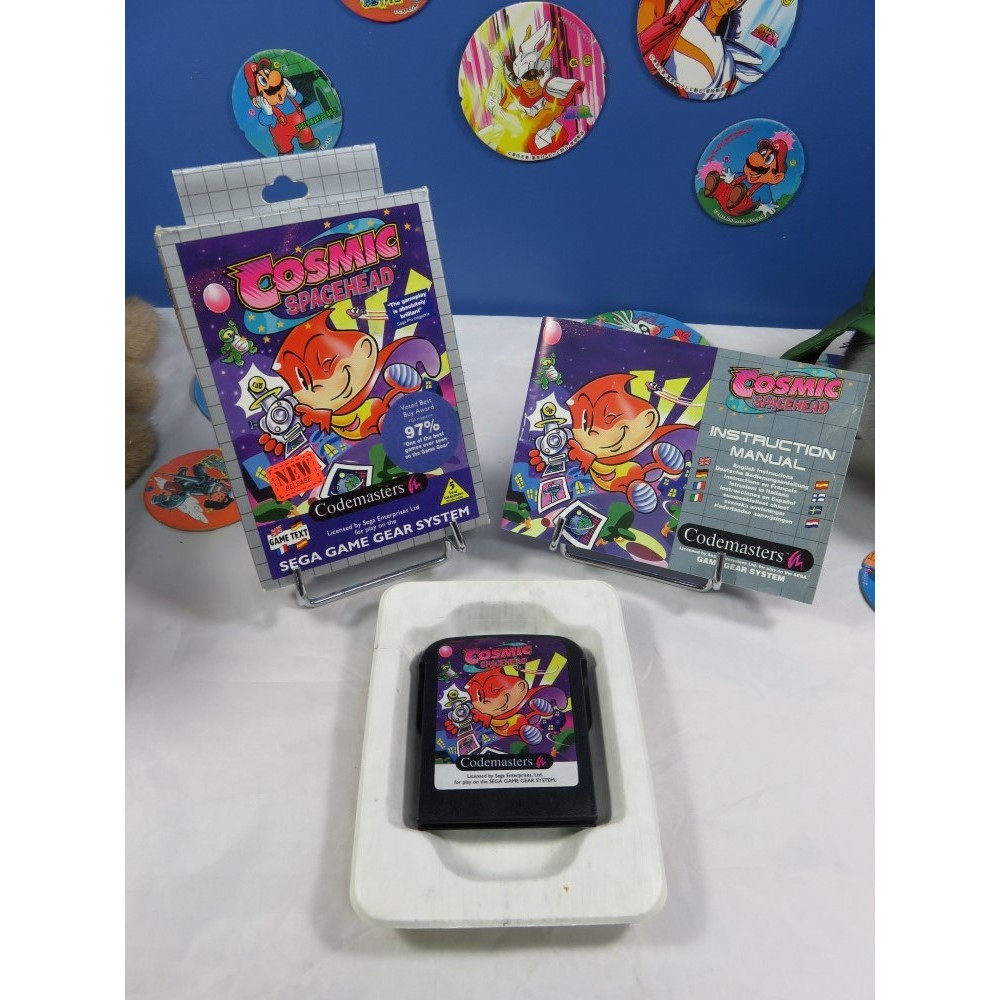Considering the elements presented, what can be deduced about the marketing strategy used for the "Cosmic Spacehead" game based on the promotional materials and packaging shown? Based on the promotional materials and packaging shown in the image, the marketing strategy for "Cosmic Spacehead" appears to be heavily focused on visually appealing and colorful artwork to captivate potential buyers. The prominent use of vibrant character designs and a high review score (97%) on the packaging suggests a strategy aimed at reassuring customers about the game's quality and entertainment value. The inclusion of a new release sticker, along with consistent branding on the promotional card and instruction manual, reinforces the game's identity and aids in brand recognition. Moreover, the assorted badges or stickers featuring different characters in the background may be part of an effort to create broader appeal and engagement by offering collectible items, further immersing players into the game's universe. 